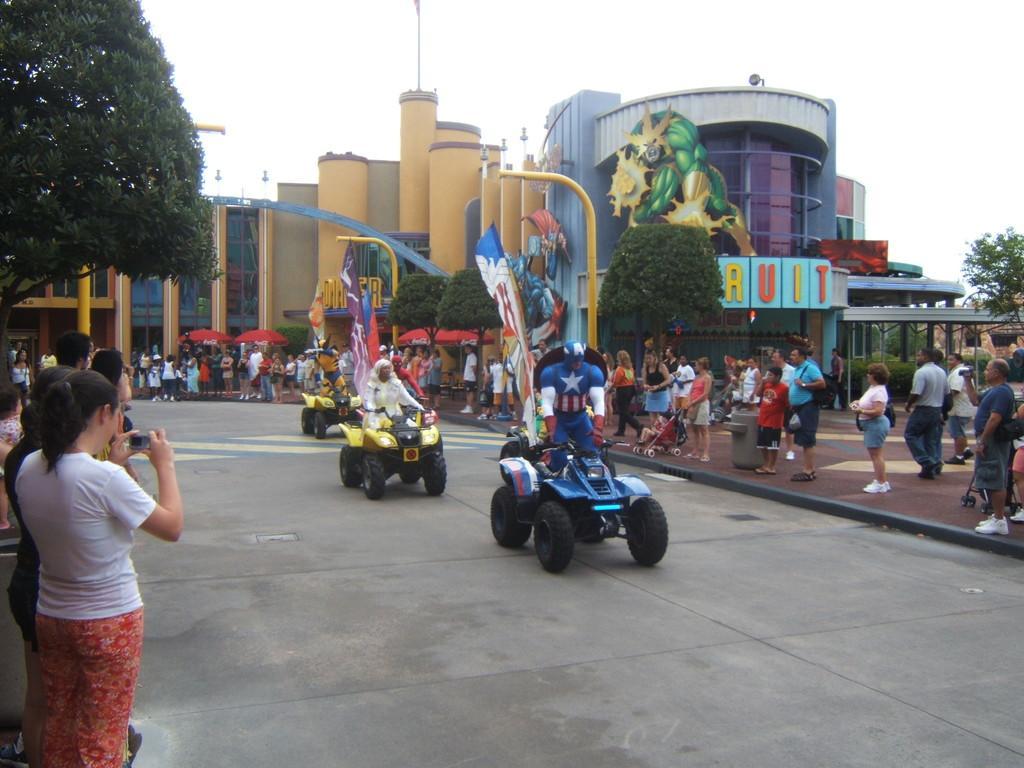In one or two sentences, can you explain what this image depicts? In this picture I can see some people were riding the vehicle. In the background I can see many people who are standing near to the buildings and trees. At the top I can see the sky. On the left there is a woman who is holding a mobile phone. 